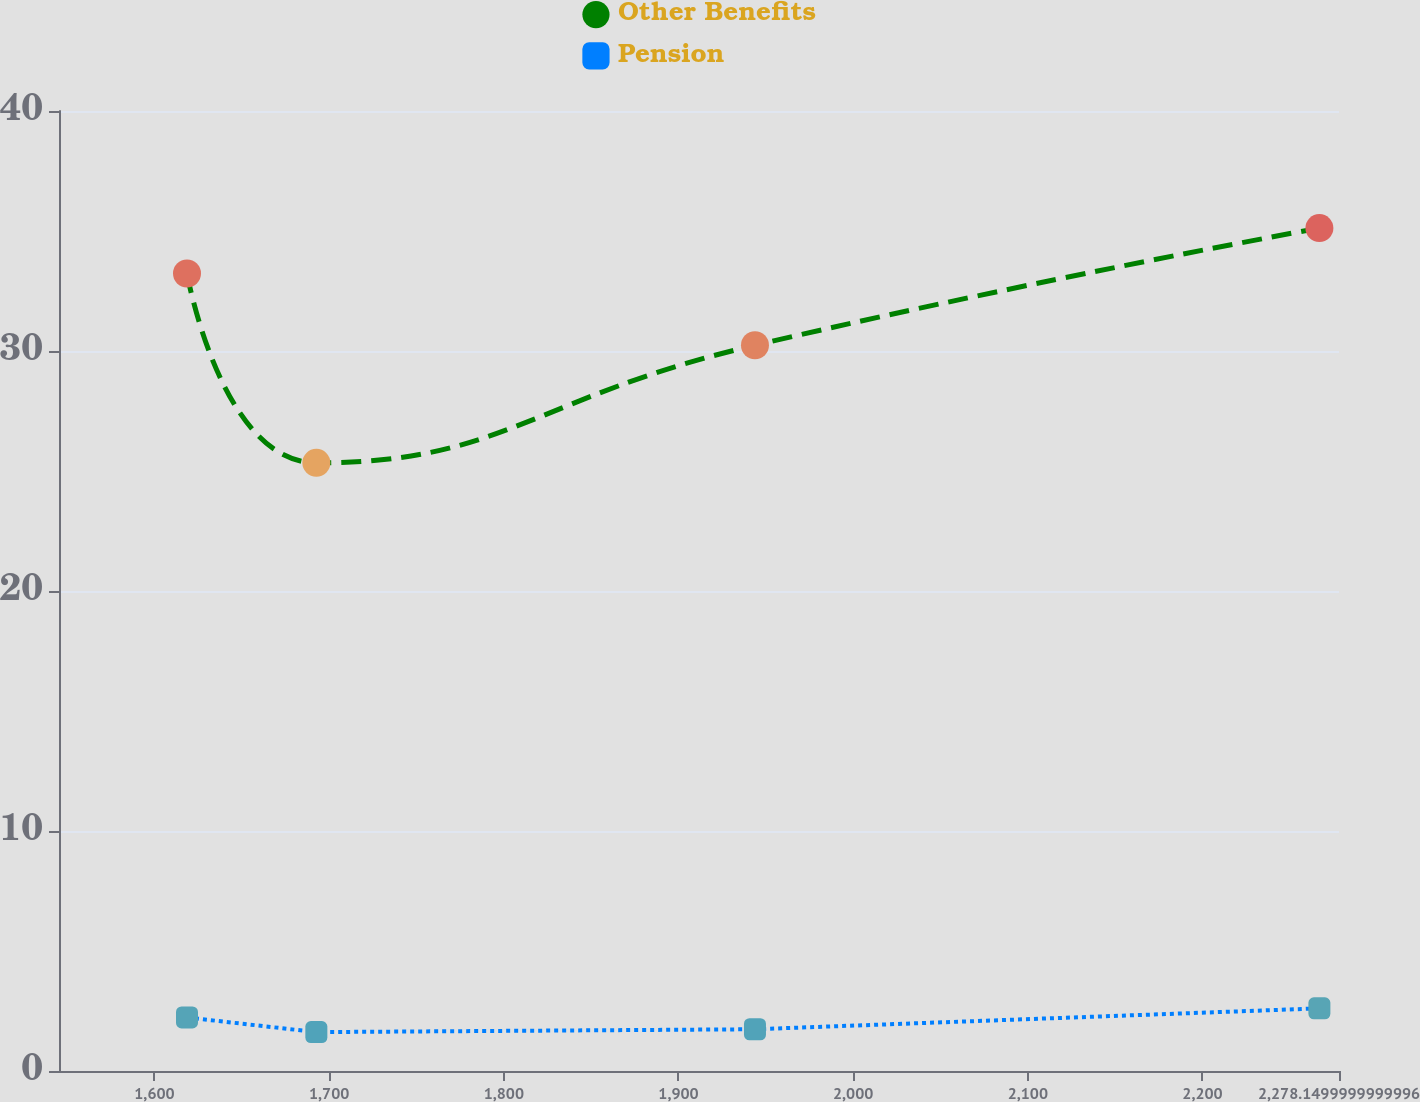<chart> <loc_0><loc_0><loc_500><loc_500><line_chart><ecel><fcel>Other Benefits<fcel>Pension<nl><fcel>1618.63<fcel>33.23<fcel>2.23<nl><fcel>1692.68<fcel>25.34<fcel>1.62<nl><fcel>1943.79<fcel>30.24<fcel>1.74<nl><fcel>2266.92<fcel>35.12<fcel>2.61<nl><fcel>2351.43<fcel>38.33<fcel>2.82<nl></chart> 